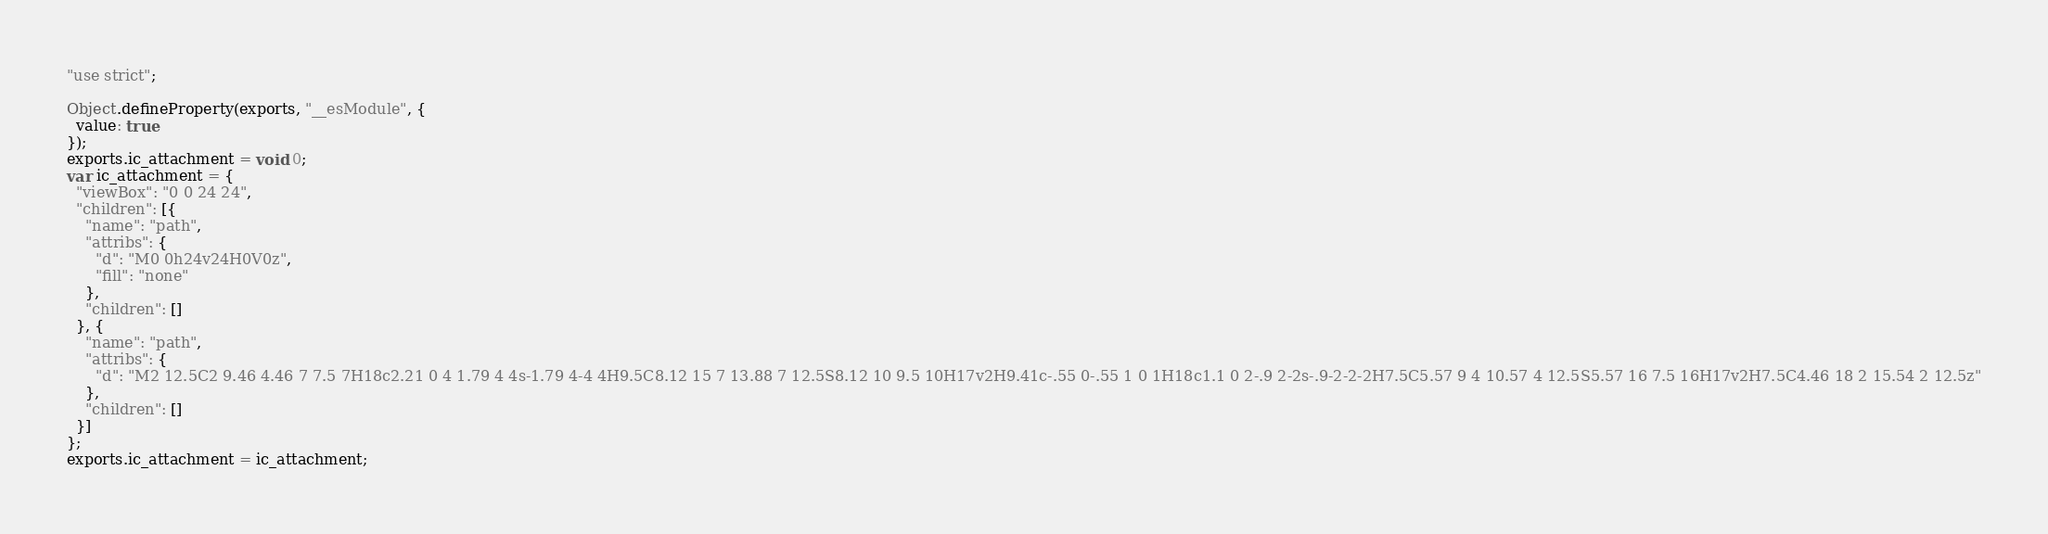<code> <loc_0><loc_0><loc_500><loc_500><_JavaScript_>"use strict";

Object.defineProperty(exports, "__esModule", {
  value: true
});
exports.ic_attachment = void 0;
var ic_attachment = {
  "viewBox": "0 0 24 24",
  "children": [{
    "name": "path",
    "attribs": {
      "d": "M0 0h24v24H0V0z",
      "fill": "none"
    },
    "children": []
  }, {
    "name": "path",
    "attribs": {
      "d": "M2 12.5C2 9.46 4.46 7 7.5 7H18c2.21 0 4 1.79 4 4s-1.79 4-4 4H9.5C8.12 15 7 13.88 7 12.5S8.12 10 9.5 10H17v2H9.41c-.55 0-.55 1 0 1H18c1.1 0 2-.9 2-2s-.9-2-2-2H7.5C5.57 9 4 10.57 4 12.5S5.57 16 7.5 16H17v2H7.5C4.46 18 2 15.54 2 12.5z"
    },
    "children": []
  }]
};
exports.ic_attachment = ic_attachment;</code> 